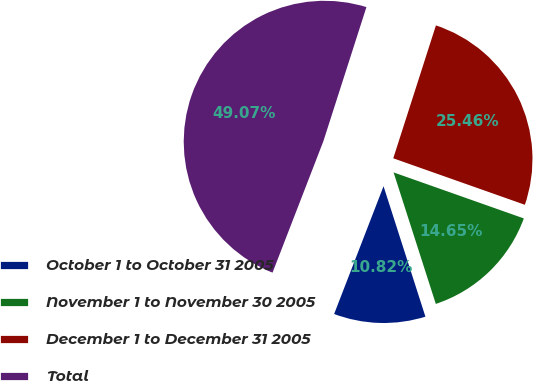Convert chart. <chart><loc_0><loc_0><loc_500><loc_500><pie_chart><fcel>October 1 to October 31 2005<fcel>November 1 to November 30 2005<fcel>December 1 to December 31 2005<fcel>Total<nl><fcel>10.82%<fcel>14.65%<fcel>25.46%<fcel>49.07%<nl></chart> 